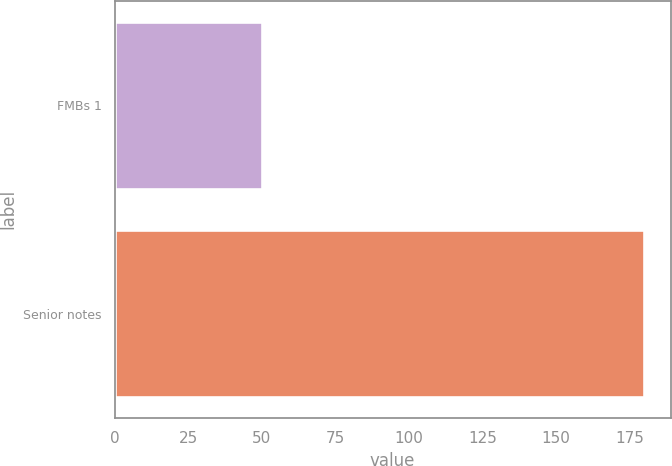Convert chart. <chart><loc_0><loc_0><loc_500><loc_500><bar_chart><fcel>FMBs 1<fcel>Senior notes<nl><fcel>50<fcel>180<nl></chart> 